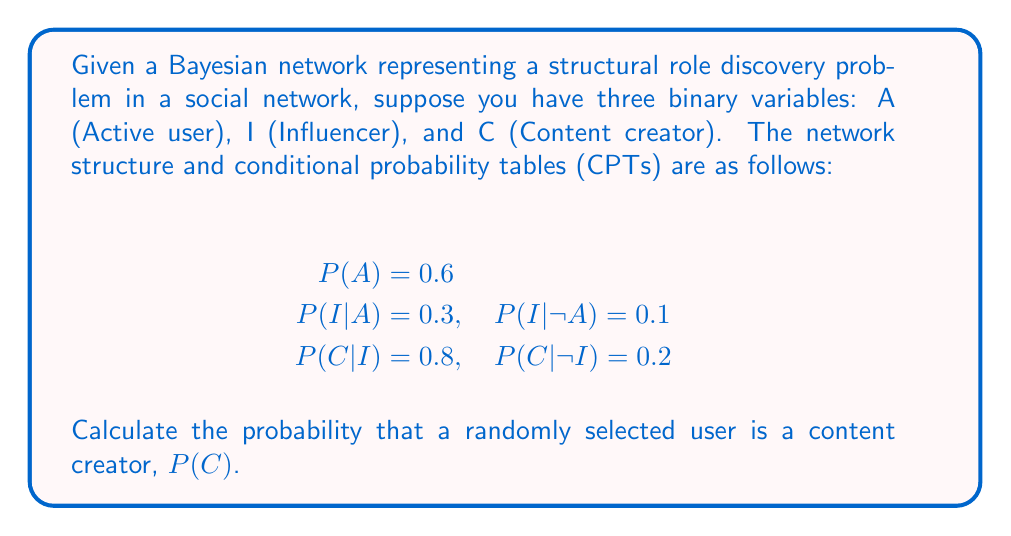Solve this math problem. To solve this problem, we'll use the law of total probability and the given conditional probabilities:

1) First, we need to calculate $P(I)$ using the law of total probability:
   $$P(I) = P(I|A)P(A) + P(I|\neg A)P(\neg A)$$

2) We know $P(A) = 0.6$, so $P(\neg A) = 1 - 0.6 = 0.4$

3) Substituting the values:
   $$P(I) = 0.3 \cdot 0.6 + 0.1 \cdot 0.4 = 0.18 + 0.04 = 0.22$$

4) Now we can calculate $P(C)$ using the law of total probability again:
   $$P(C) = P(C|I)P(I) + P(C|\neg I)P(\neg I)$$

5) We know $P(I) = 0.22$, so $P(\neg I) = 1 - 0.22 = 0.78$

6) Substituting the values:
   $$P(C) = 0.8 \cdot 0.22 + 0.2 \cdot 0.78 = 0.176 + 0.156 = 0.332$$

Therefore, the probability that a randomly selected user is a content creator is 0.332 or 33.2%.
Answer: 0.332 